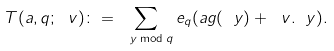Convert formula to latex. <formula><loc_0><loc_0><loc_500><loc_500>T ( a , q ; \ v ) \colon = \sum _ { \ y \bmod { q } } e _ { q } ( a g ( \ y ) + \ v . \ y ) .</formula> 